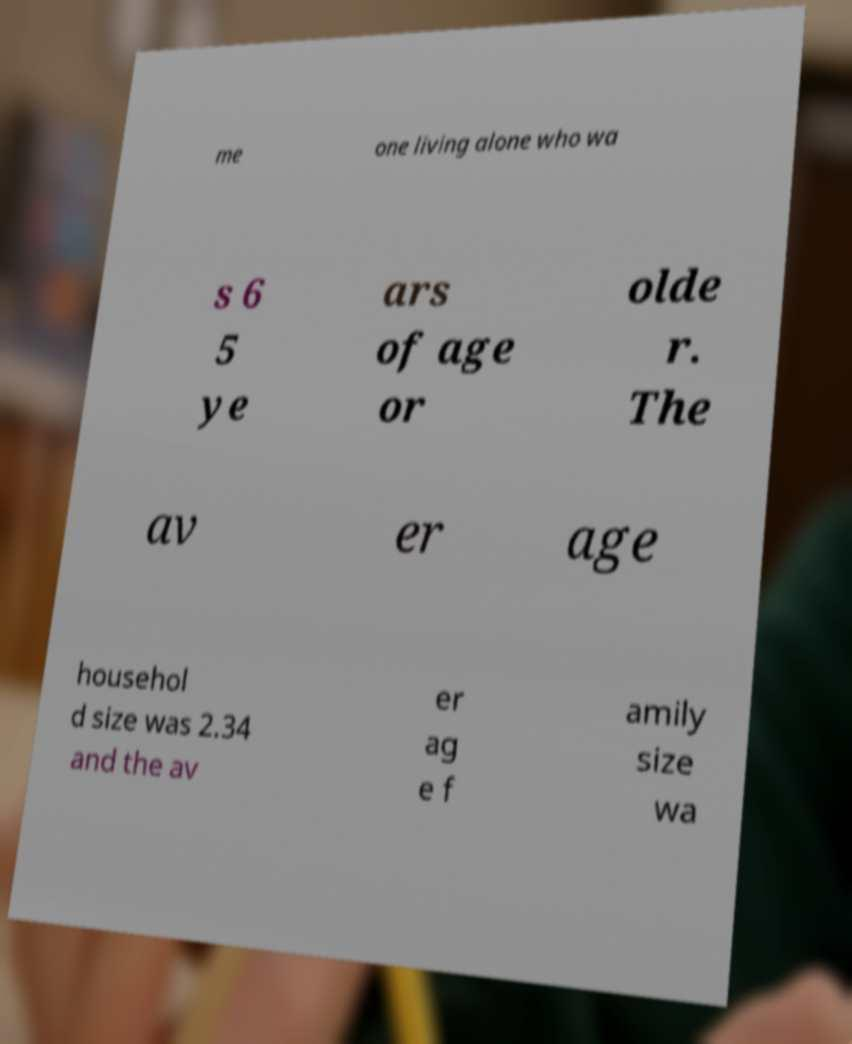There's text embedded in this image that I need extracted. Can you transcribe it verbatim? me one living alone who wa s 6 5 ye ars of age or olde r. The av er age househol d size was 2.34 and the av er ag e f amily size wa 